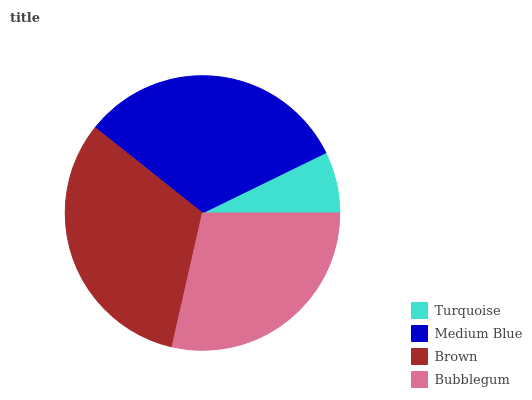Is Turquoise the minimum?
Answer yes or no. Yes. Is Brown the maximum?
Answer yes or no. Yes. Is Medium Blue the minimum?
Answer yes or no. No. Is Medium Blue the maximum?
Answer yes or no. No. Is Medium Blue greater than Turquoise?
Answer yes or no. Yes. Is Turquoise less than Medium Blue?
Answer yes or no. Yes. Is Turquoise greater than Medium Blue?
Answer yes or no. No. Is Medium Blue less than Turquoise?
Answer yes or no. No. Is Medium Blue the high median?
Answer yes or no. Yes. Is Bubblegum the low median?
Answer yes or no. Yes. Is Brown the high median?
Answer yes or no. No. Is Turquoise the low median?
Answer yes or no. No. 